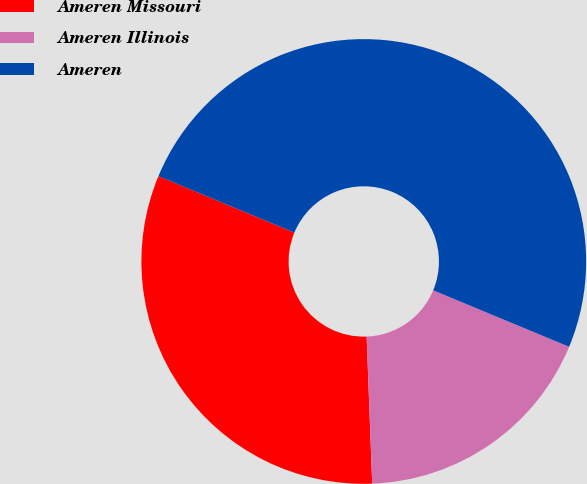<chart> <loc_0><loc_0><loc_500><loc_500><pie_chart><fcel>Ameren Missouri<fcel>Ameren Illinois<fcel>Ameren<nl><fcel>31.87%<fcel>18.13%<fcel>50.0%<nl></chart> 